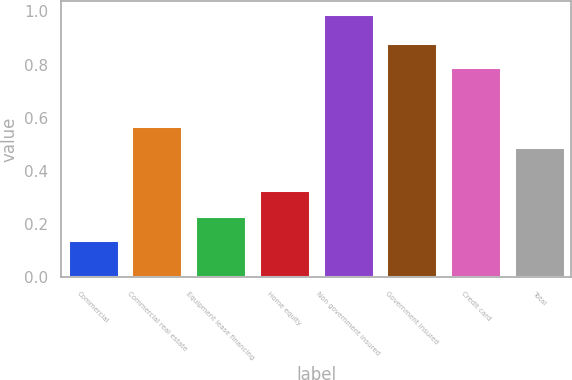Convert chart to OTSL. <chart><loc_0><loc_0><loc_500><loc_500><bar_chart><fcel>Commercial<fcel>Commercial real estate<fcel>Equipment lease financing<fcel>Home equity<fcel>Non government insured<fcel>Government insured<fcel>Credit card<fcel>Total<nl><fcel>0.14<fcel>0.57<fcel>0.23<fcel>0.33<fcel>0.99<fcel>0.88<fcel>0.79<fcel>0.49<nl></chart> 